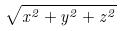Convert formula to latex. <formula><loc_0><loc_0><loc_500><loc_500>\sqrt { x ^ { 2 } + y ^ { 2 } + z ^ { 2 } }</formula> 